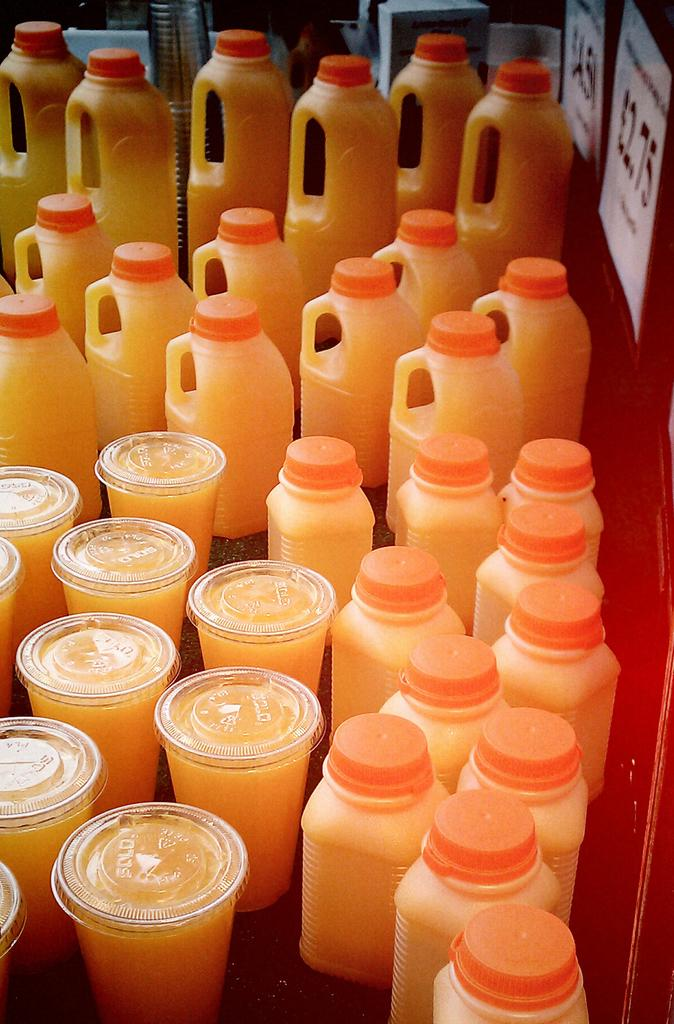What types of containers are visible in the image? There are bottles, glasses, and jars in the image. What is inside the containers in the image? The bottles, glasses, and jars are filled with liquid. What can be seen behind the containers in the image? The background of the items is a wall. What type of advertisement is displayed on the wall behind the containers? There is no advertisement present in the image; the background is simply a wall. Is there a bat visible in the image? There is no bat present in the image. 